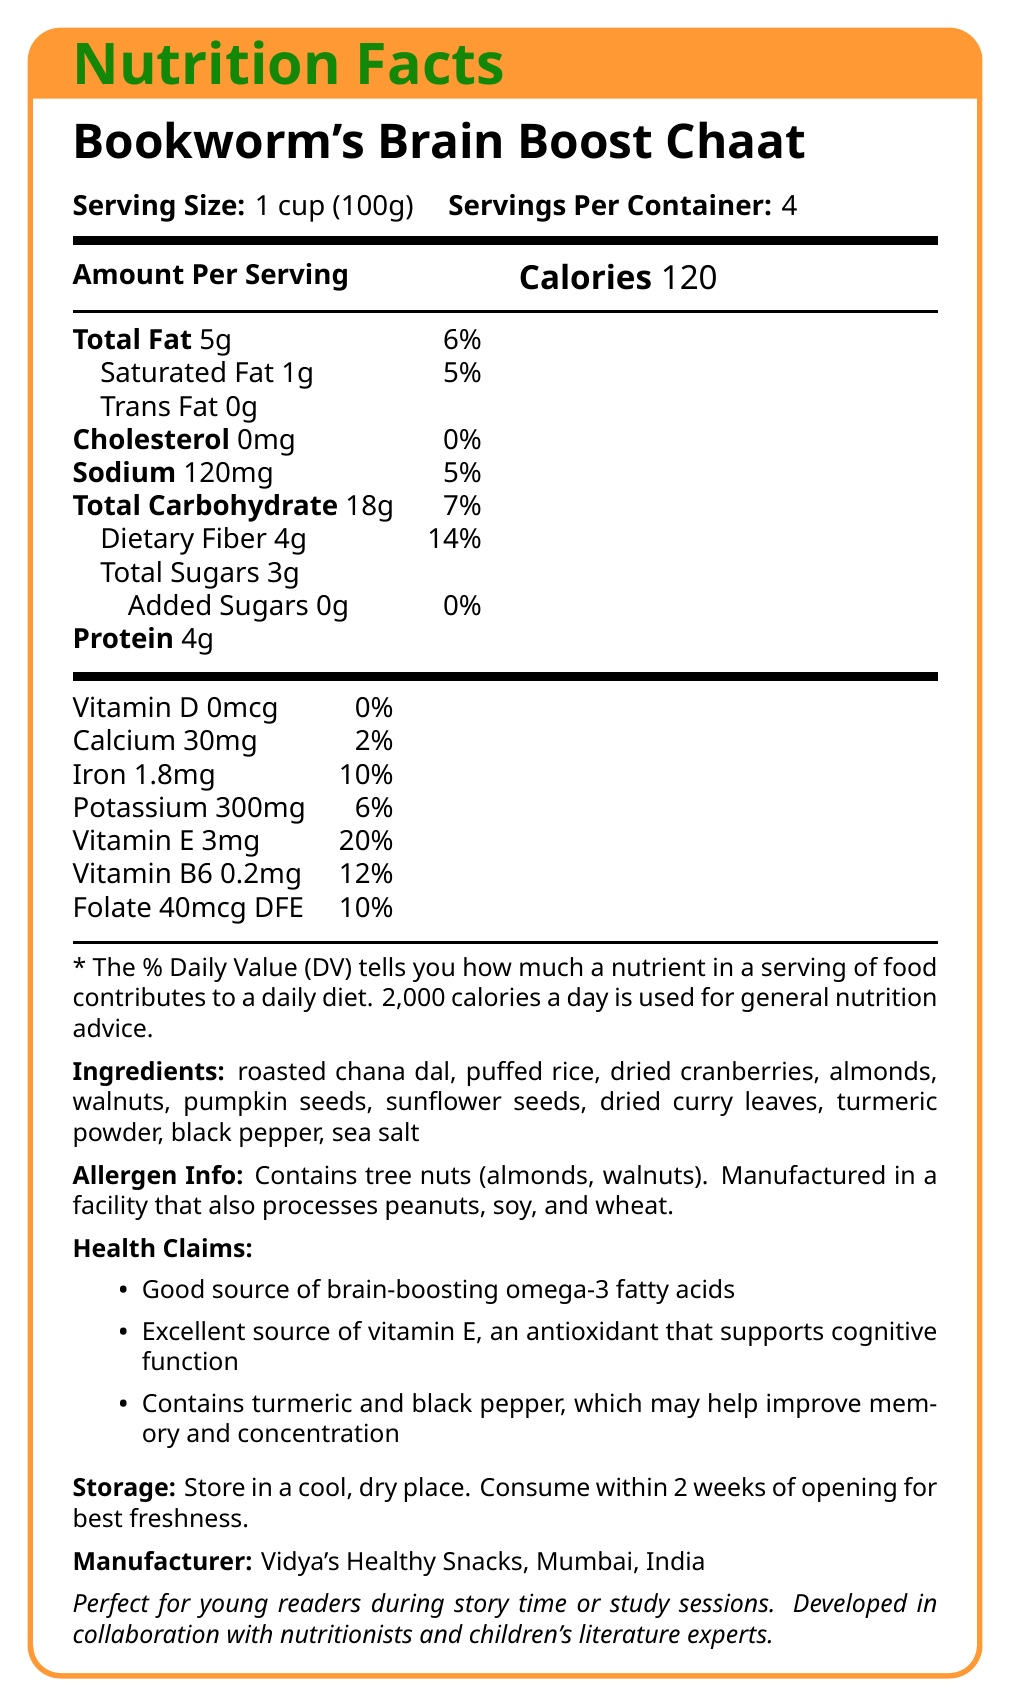What is the serving size for Bookworm's Brain Boost Chaat? The serving size is indicated in the document as "Serving Size: 1 cup (100g)".
Answer: 1 cup (100g) How many servings are there per container? The document specifies "Servings Per Container: 4".
Answer: 4 What is the total amount of fat per serving? The document lists "Total Fat: 5g" in the nutritional information.
Answer: 5g Can you find any allergens mentioned in this snack? The allergen information section mentions "Contains tree nuts (almonds, walnuts)".
Answer: Contains tree nuts (almonds, walnuts) What is the recommended storage instruction for this snack? The storage instructions state "Store in a cool, dry place. Consume within 2 weeks of opening for best freshness."
Answer: Store in a cool, dry place. Consume within 2 weeks of opening for best freshness. How many calories are there per serving of Bookworm's Brain Boost Chaat? The document indicates "Calories: 120" per serving.
Answer: 120 What percentage of the daily value for Vitamin E does one serving provide? A. 10% B. 20% C. 5% D. 0% The nutritional facts specify "Vitamin E: 3mg (20%)".
Answer: B. 20% How much dietary fiber is in one serving of this snack? A. 2g B. 6g C. 4g D. 8g The nutritional information lists "Dietary Fiber: 4g".
Answer: C. 4g Does this product contain any added sugars? Yes/No The document indicates "Added Sugars: 0g".
Answer: No Which of the following health benefits is supported by this snack? A. Rich in Vitamin C B. High in Fiber C. Excellent Source of Vitamin E D. Good source of Calcium The health claims section states it as an excellent source of vitamin E.
Answer: C. Excellent Source of Vitamin E Describe the main idea of the document. The document is a comprehensive nutrition facts label that gives details on serving size, calories, fats, vitamins, ingredients, allergen warnings, health benefits, manufacturer information, and storage instructions for the snack product.
Answer: A nutrition facts label for Bookworm's Brain Boost Chaat that provides nutritional information, ingredients, allergen info, health benefits, and storage instructions for a healthy, brain-boosting snack. What is the exact amount of Vitamin B12 in this snack? The document does not provide any information on Vitamin B12 content.
Answer: Cannot be determined 